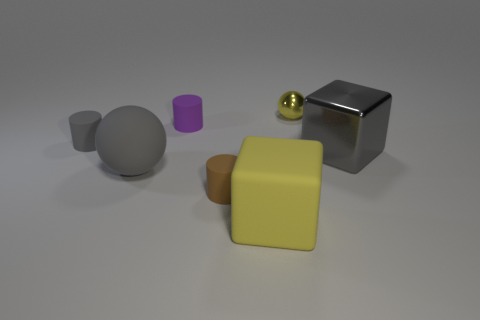There is a rubber ball that is the same size as the gray metallic cube; what color is it?
Provide a short and direct response. Gray. Are there fewer large gray metallic blocks that are in front of the large rubber sphere than large gray metal things that are in front of the small brown cylinder?
Provide a succinct answer. No. The tiny purple thing on the left side of the block that is right of the matte object that is in front of the brown object is what shape?
Make the answer very short. Cylinder. Does the matte cylinder that is behind the tiny gray cylinder have the same color as the ball to the right of the yellow matte block?
Your response must be concise. No. There is a big object that is the same color as the tiny shiny object; what shape is it?
Your answer should be very brief. Cube. How many matte objects are cubes or large gray objects?
Your response must be concise. 2. There is a big object that is in front of the brown matte cylinder on the left side of the large cube that is behind the gray rubber ball; what is its color?
Provide a succinct answer. Yellow. The big matte object that is the same shape as the yellow metallic thing is what color?
Provide a short and direct response. Gray. Are there any other things of the same color as the big rubber cube?
Keep it short and to the point. Yes. How many other objects are there of the same material as the gray cube?
Provide a short and direct response. 1. 